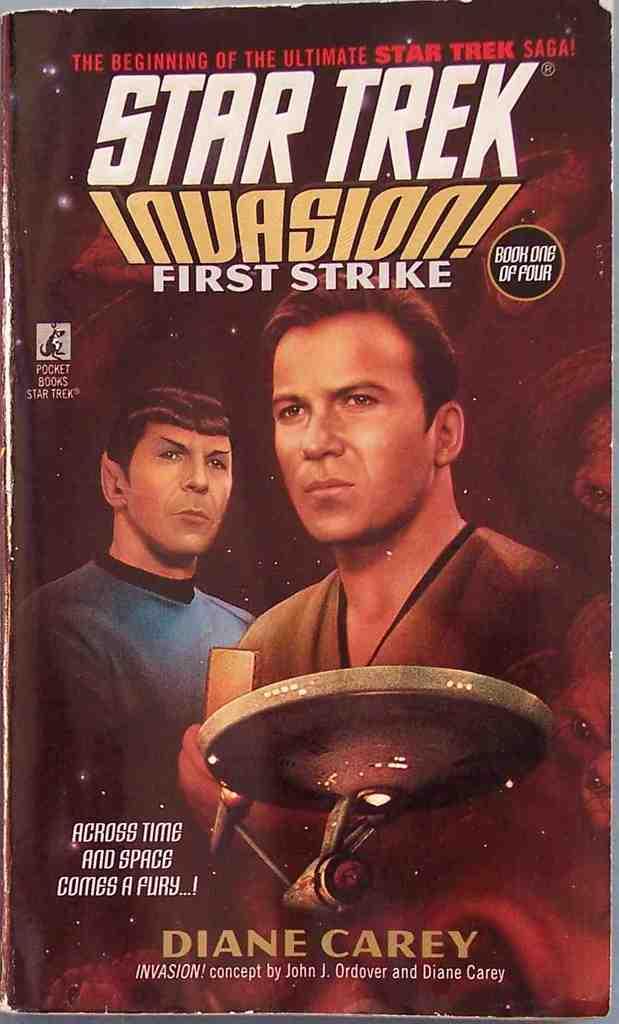Who is the author of this book?
Your answer should be very brief. Diane carey. What is the title?
Your answer should be compact. Star trek invasion! first strike. 